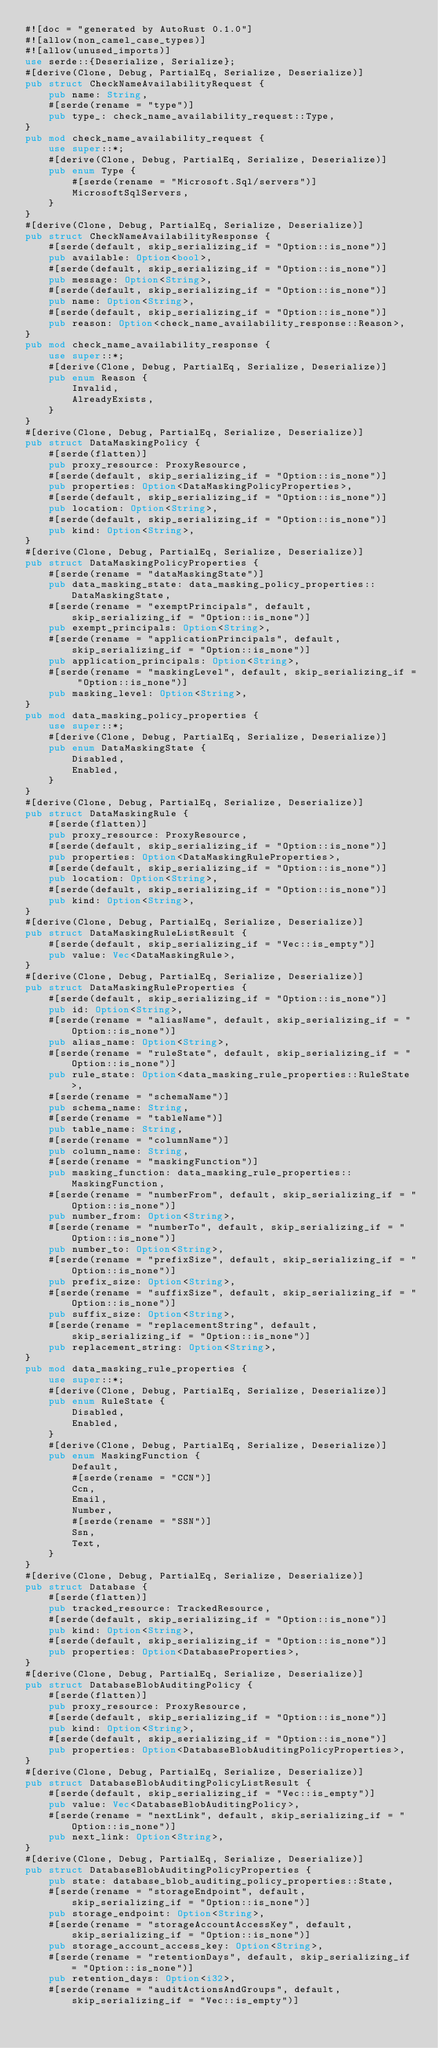<code> <loc_0><loc_0><loc_500><loc_500><_Rust_>#![doc = "generated by AutoRust 0.1.0"]
#![allow(non_camel_case_types)]
#![allow(unused_imports)]
use serde::{Deserialize, Serialize};
#[derive(Clone, Debug, PartialEq, Serialize, Deserialize)]
pub struct CheckNameAvailabilityRequest {
    pub name: String,
    #[serde(rename = "type")]
    pub type_: check_name_availability_request::Type,
}
pub mod check_name_availability_request {
    use super::*;
    #[derive(Clone, Debug, PartialEq, Serialize, Deserialize)]
    pub enum Type {
        #[serde(rename = "Microsoft.Sql/servers")]
        MicrosoftSqlServers,
    }
}
#[derive(Clone, Debug, PartialEq, Serialize, Deserialize)]
pub struct CheckNameAvailabilityResponse {
    #[serde(default, skip_serializing_if = "Option::is_none")]
    pub available: Option<bool>,
    #[serde(default, skip_serializing_if = "Option::is_none")]
    pub message: Option<String>,
    #[serde(default, skip_serializing_if = "Option::is_none")]
    pub name: Option<String>,
    #[serde(default, skip_serializing_if = "Option::is_none")]
    pub reason: Option<check_name_availability_response::Reason>,
}
pub mod check_name_availability_response {
    use super::*;
    #[derive(Clone, Debug, PartialEq, Serialize, Deserialize)]
    pub enum Reason {
        Invalid,
        AlreadyExists,
    }
}
#[derive(Clone, Debug, PartialEq, Serialize, Deserialize)]
pub struct DataMaskingPolicy {
    #[serde(flatten)]
    pub proxy_resource: ProxyResource,
    #[serde(default, skip_serializing_if = "Option::is_none")]
    pub properties: Option<DataMaskingPolicyProperties>,
    #[serde(default, skip_serializing_if = "Option::is_none")]
    pub location: Option<String>,
    #[serde(default, skip_serializing_if = "Option::is_none")]
    pub kind: Option<String>,
}
#[derive(Clone, Debug, PartialEq, Serialize, Deserialize)]
pub struct DataMaskingPolicyProperties {
    #[serde(rename = "dataMaskingState")]
    pub data_masking_state: data_masking_policy_properties::DataMaskingState,
    #[serde(rename = "exemptPrincipals", default, skip_serializing_if = "Option::is_none")]
    pub exempt_principals: Option<String>,
    #[serde(rename = "applicationPrincipals", default, skip_serializing_if = "Option::is_none")]
    pub application_principals: Option<String>,
    #[serde(rename = "maskingLevel", default, skip_serializing_if = "Option::is_none")]
    pub masking_level: Option<String>,
}
pub mod data_masking_policy_properties {
    use super::*;
    #[derive(Clone, Debug, PartialEq, Serialize, Deserialize)]
    pub enum DataMaskingState {
        Disabled,
        Enabled,
    }
}
#[derive(Clone, Debug, PartialEq, Serialize, Deserialize)]
pub struct DataMaskingRule {
    #[serde(flatten)]
    pub proxy_resource: ProxyResource,
    #[serde(default, skip_serializing_if = "Option::is_none")]
    pub properties: Option<DataMaskingRuleProperties>,
    #[serde(default, skip_serializing_if = "Option::is_none")]
    pub location: Option<String>,
    #[serde(default, skip_serializing_if = "Option::is_none")]
    pub kind: Option<String>,
}
#[derive(Clone, Debug, PartialEq, Serialize, Deserialize)]
pub struct DataMaskingRuleListResult {
    #[serde(default, skip_serializing_if = "Vec::is_empty")]
    pub value: Vec<DataMaskingRule>,
}
#[derive(Clone, Debug, PartialEq, Serialize, Deserialize)]
pub struct DataMaskingRuleProperties {
    #[serde(default, skip_serializing_if = "Option::is_none")]
    pub id: Option<String>,
    #[serde(rename = "aliasName", default, skip_serializing_if = "Option::is_none")]
    pub alias_name: Option<String>,
    #[serde(rename = "ruleState", default, skip_serializing_if = "Option::is_none")]
    pub rule_state: Option<data_masking_rule_properties::RuleState>,
    #[serde(rename = "schemaName")]
    pub schema_name: String,
    #[serde(rename = "tableName")]
    pub table_name: String,
    #[serde(rename = "columnName")]
    pub column_name: String,
    #[serde(rename = "maskingFunction")]
    pub masking_function: data_masking_rule_properties::MaskingFunction,
    #[serde(rename = "numberFrom", default, skip_serializing_if = "Option::is_none")]
    pub number_from: Option<String>,
    #[serde(rename = "numberTo", default, skip_serializing_if = "Option::is_none")]
    pub number_to: Option<String>,
    #[serde(rename = "prefixSize", default, skip_serializing_if = "Option::is_none")]
    pub prefix_size: Option<String>,
    #[serde(rename = "suffixSize", default, skip_serializing_if = "Option::is_none")]
    pub suffix_size: Option<String>,
    #[serde(rename = "replacementString", default, skip_serializing_if = "Option::is_none")]
    pub replacement_string: Option<String>,
}
pub mod data_masking_rule_properties {
    use super::*;
    #[derive(Clone, Debug, PartialEq, Serialize, Deserialize)]
    pub enum RuleState {
        Disabled,
        Enabled,
    }
    #[derive(Clone, Debug, PartialEq, Serialize, Deserialize)]
    pub enum MaskingFunction {
        Default,
        #[serde(rename = "CCN")]
        Ccn,
        Email,
        Number,
        #[serde(rename = "SSN")]
        Ssn,
        Text,
    }
}
#[derive(Clone, Debug, PartialEq, Serialize, Deserialize)]
pub struct Database {
    #[serde(flatten)]
    pub tracked_resource: TrackedResource,
    #[serde(default, skip_serializing_if = "Option::is_none")]
    pub kind: Option<String>,
    #[serde(default, skip_serializing_if = "Option::is_none")]
    pub properties: Option<DatabaseProperties>,
}
#[derive(Clone, Debug, PartialEq, Serialize, Deserialize)]
pub struct DatabaseBlobAuditingPolicy {
    #[serde(flatten)]
    pub proxy_resource: ProxyResource,
    #[serde(default, skip_serializing_if = "Option::is_none")]
    pub kind: Option<String>,
    #[serde(default, skip_serializing_if = "Option::is_none")]
    pub properties: Option<DatabaseBlobAuditingPolicyProperties>,
}
#[derive(Clone, Debug, PartialEq, Serialize, Deserialize)]
pub struct DatabaseBlobAuditingPolicyListResult {
    #[serde(default, skip_serializing_if = "Vec::is_empty")]
    pub value: Vec<DatabaseBlobAuditingPolicy>,
    #[serde(rename = "nextLink", default, skip_serializing_if = "Option::is_none")]
    pub next_link: Option<String>,
}
#[derive(Clone, Debug, PartialEq, Serialize, Deserialize)]
pub struct DatabaseBlobAuditingPolicyProperties {
    pub state: database_blob_auditing_policy_properties::State,
    #[serde(rename = "storageEndpoint", default, skip_serializing_if = "Option::is_none")]
    pub storage_endpoint: Option<String>,
    #[serde(rename = "storageAccountAccessKey", default, skip_serializing_if = "Option::is_none")]
    pub storage_account_access_key: Option<String>,
    #[serde(rename = "retentionDays", default, skip_serializing_if = "Option::is_none")]
    pub retention_days: Option<i32>,
    #[serde(rename = "auditActionsAndGroups", default, skip_serializing_if = "Vec::is_empty")]</code> 